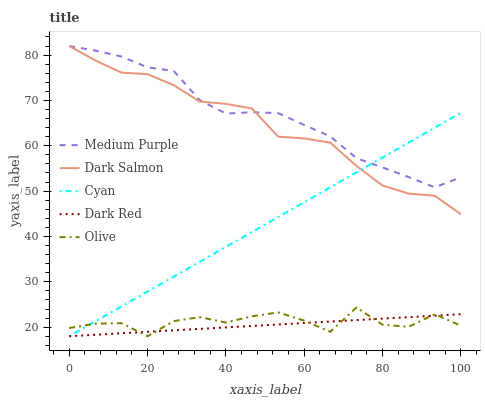Does Cyan have the minimum area under the curve?
Answer yes or no. No. Does Cyan have the maximum area under the curve?
Answer yes or no. No. Is Cyan the smoothest?
Answer yes or no. No. Is Cyan the roughest?
Answer yes or no. No. Does Dark Salmon have the lowest value?
Answer yes or no. No. Does Cyan have the highest value?
Answer yes or no. No. Is Olive less than Dark Salmon?
Answer yes or no. Yes. Is Medium Purple greater than Olive?
Answer yes or no. Yes. Does Olive intersect Dark Salmon?
Answer yes or no. No. 